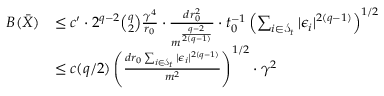Convert formula to latex. <formula><loc_0><loc_0><loc_500><loc_500>\begin{array} { r l } { B ( \bar { X } ) } & { \leq c ^ { \prime } \cdot 2 ^ { q - 2 } \binom { q } { 2 } \frac { \gamma ^ { 4 } } { r _ { 0 } } \cdot \frac { d r _ { 0 } ^ { 2 } } { m ^ { \frac { q - 2 } { 2 ( q - 1 ) } } } \cdot t _ { 0 } ^ { - 1 } \left ( \sum _ { i \in \mathcal { S } _ { t } } | \epsilon _ { i } | ^ { 2 ( q - 1 ) } \right ) ^ { 1 / 2 } } \\ & { \leq c ( q / 2 ) \left ( \frac { d r _ { 0 } \sum _ { i \in \mathcal { S } _ { t } } | \epsilon _ { i } | ^ { 2 ( q - 1 ) } } { m ^ { 2 } } \right ) ^ { 1 / 2 } \cdot \gamma ^ { 2 } } \end{array}</formula> 